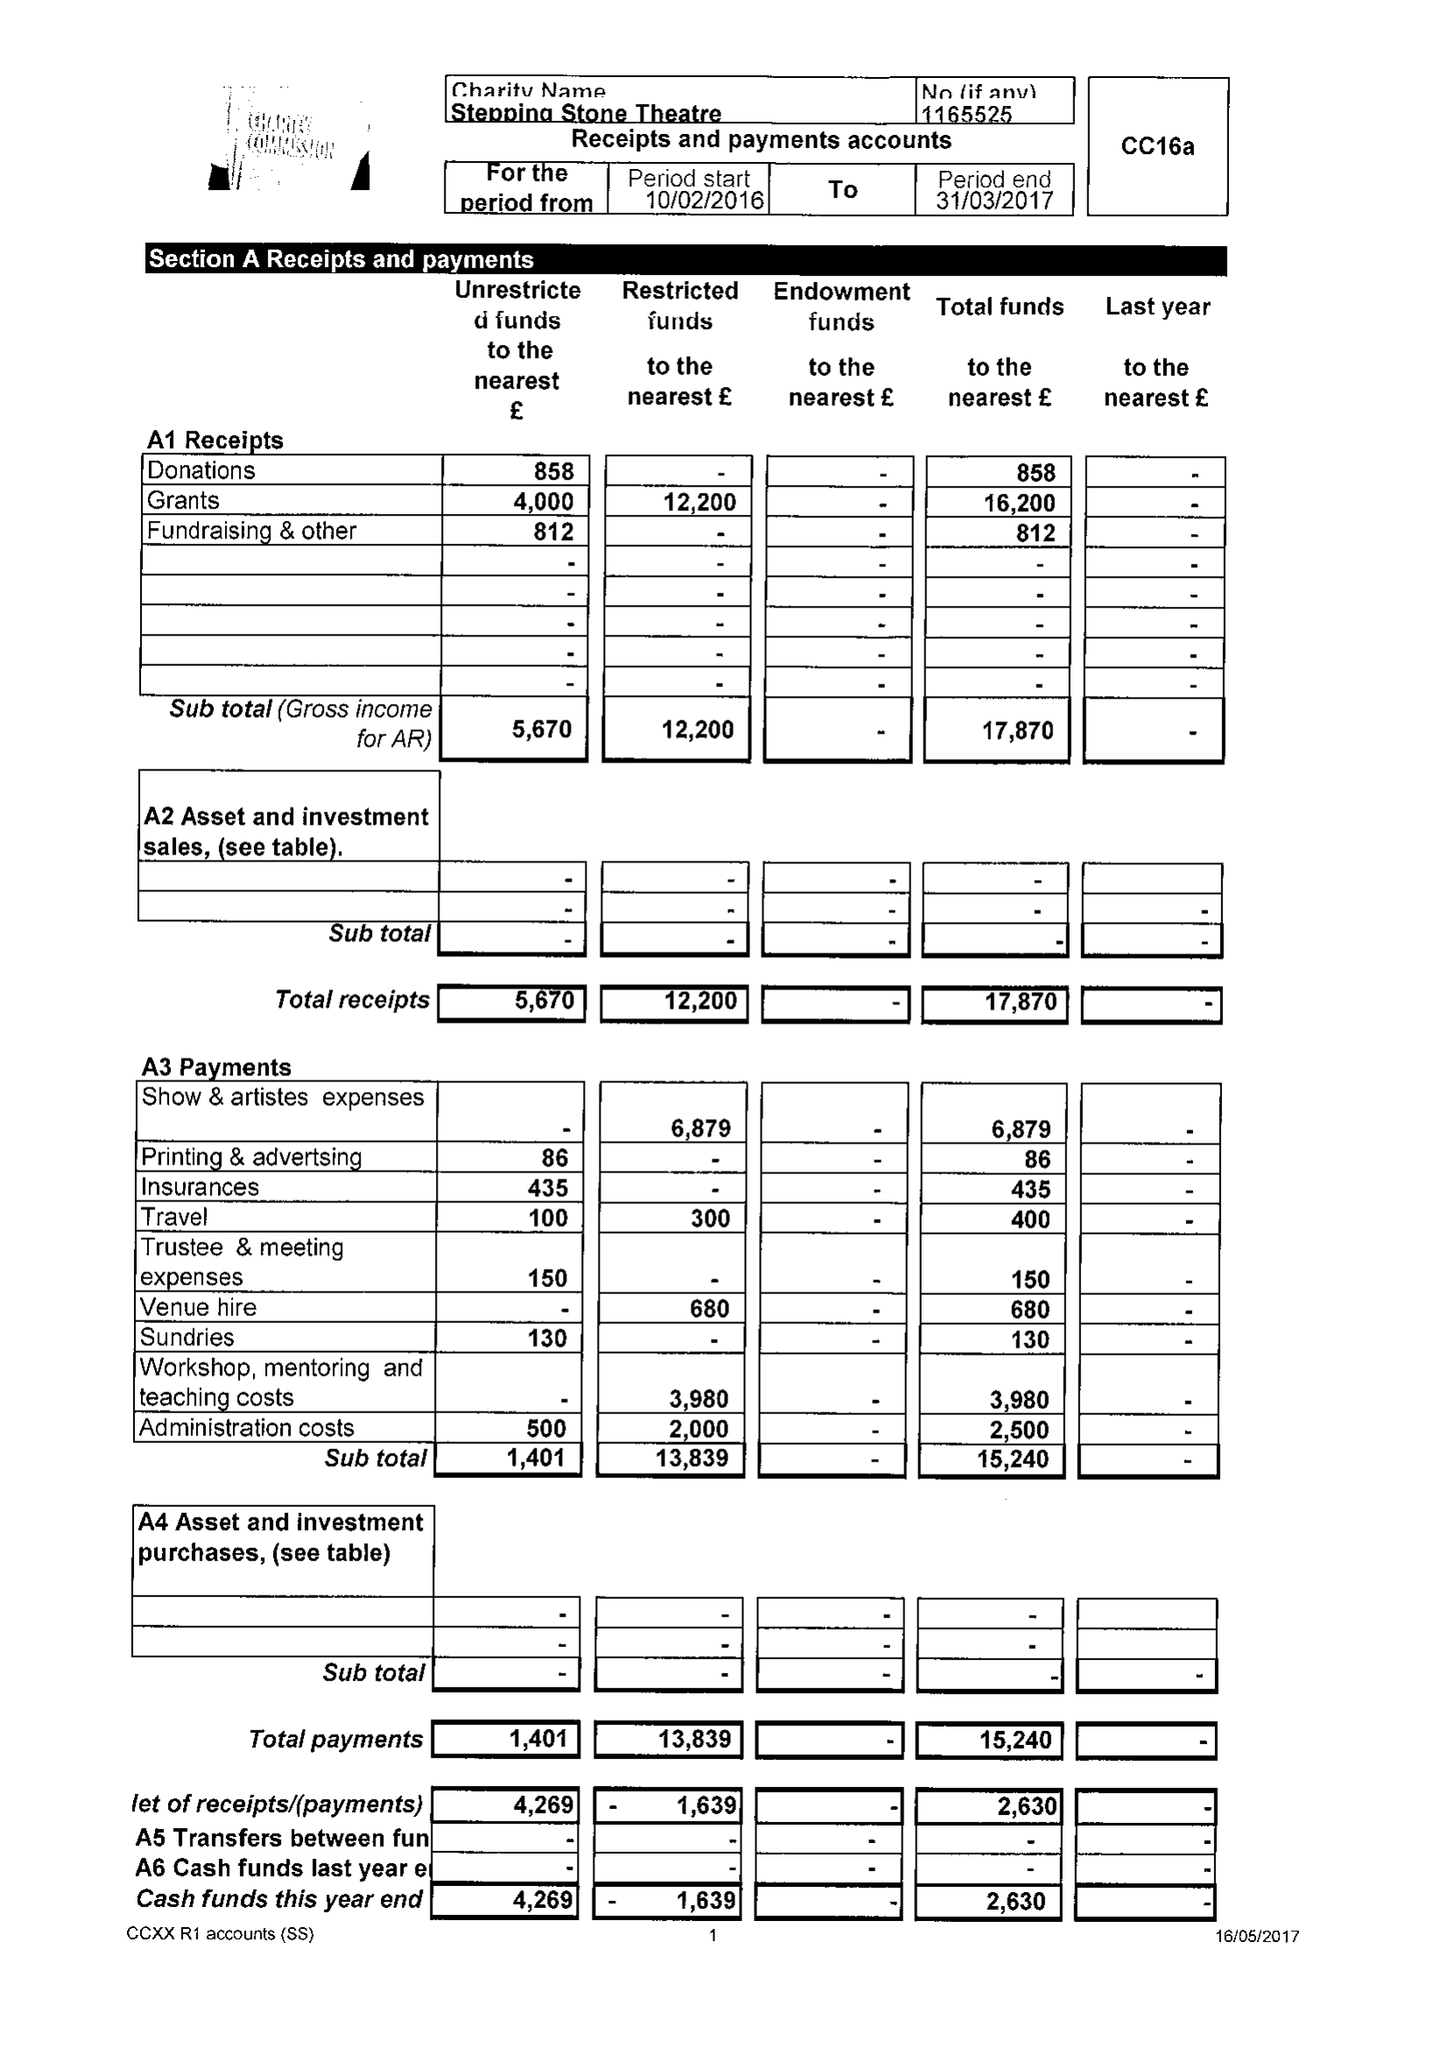What is the value for the address__street_line?
Answer the question using a single word or phrase. 3 CHURCH LANE 